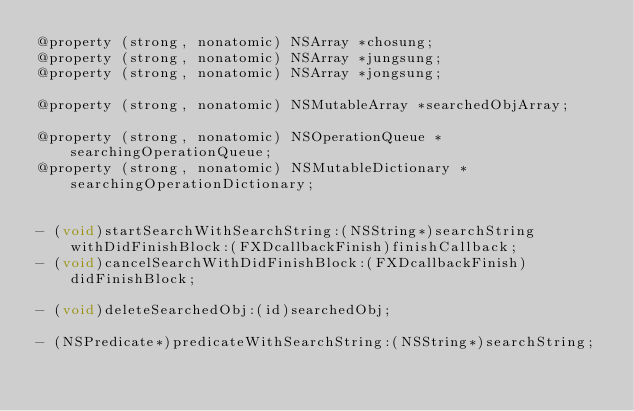<code> <loc_0><loc_0><loc_500><loc_500><_C_>@property (strong, nonatomic) NSArray *chosung;
@property (strong, nonatomic) NSArray *jungsung;
@property (strong, nonatomic) NSArray *jongsung;

@property (strong, nonatomic) NSMutableArray *searchedObjArray;

@property (strong, nonatomic) NSOperationQueue *searchingOperationQueue;
@property (strong, nonatomic) NSMutableDictionary *searchingOperationDictionary;


- (void)startSearchWithSearchString:(NSString*)searchString withDidFinishBlock:(FXDcallbackFinish)finishCallback;
- (void)cancelSearchWithDidFinishBlock:(FXDcallbackFinish)didFinishBlock;

- (void)deleteSearchedObj:(id)searchedObj;

- (NSPredicate*)predicateWithSearchString:(NSString*)searchString;</code> 